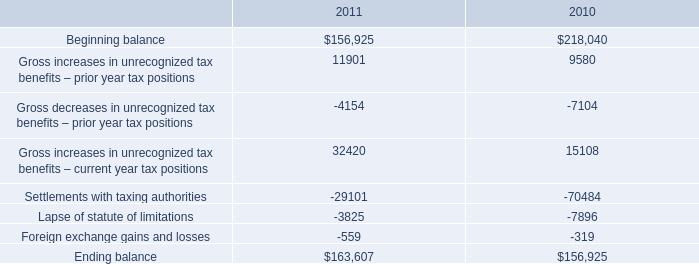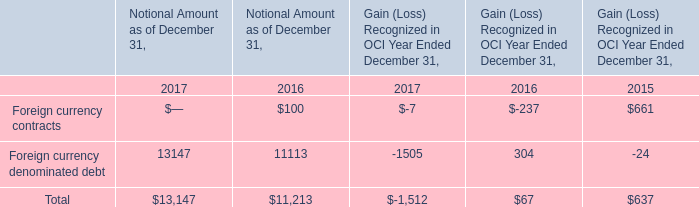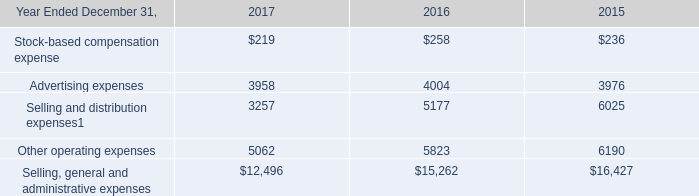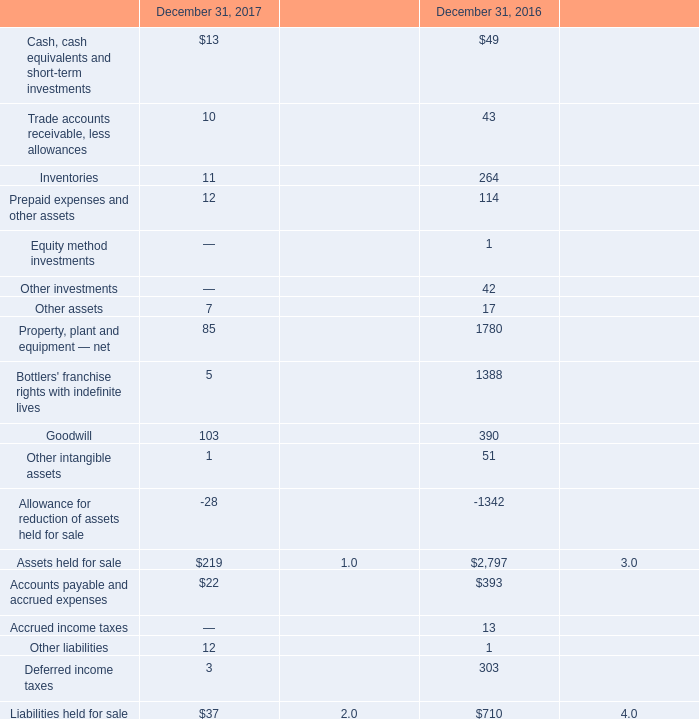what is the growth rate in the balance of unrecognized tax benefits during 2010? 
Computations: ((156925 - 218040) / 218040)
Answer: -0.28029. 